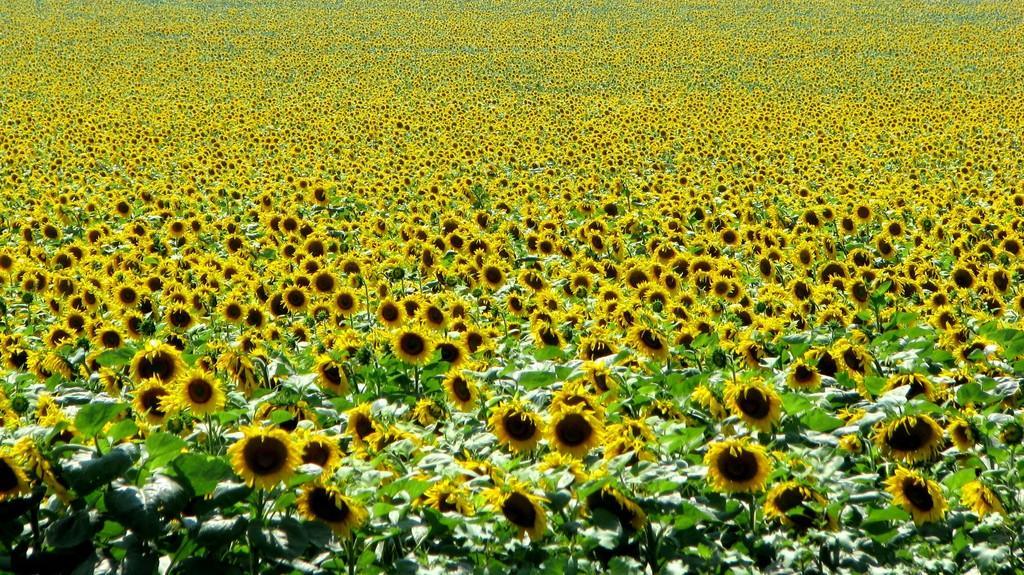How would you summarize this image in a sentence or two? In this picture we can see sunflower plant field. 